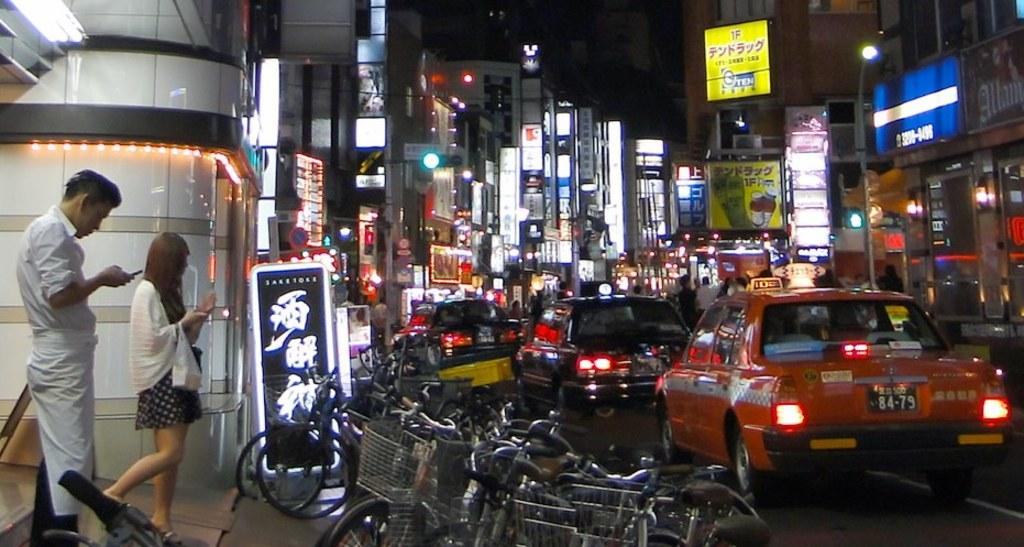<image>
Create a compact narrative representing the image presented. The license plate on the orange taxi is 84-79. 